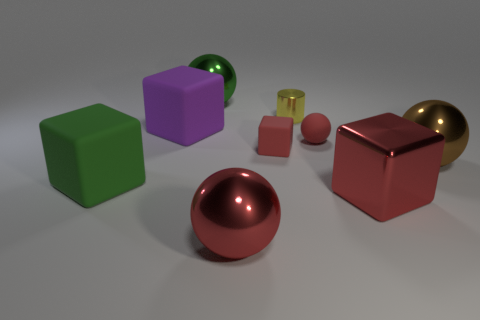What might the different colors and shapes represent if this were a metaphorical composition? If we interpret the image metaphorically, the various colors and shapes can symbolize diversity and individuality. The distinct colors represent different characteristics or identities, while the geometric shapes might symbolize the various roles or personas that individuals can assume. The spherical objects, with their reflective surfaces, could be seen as focal points of insight or self-reflection, drawing attention to the value of looking beyond the surface to discover depth and complexity. 